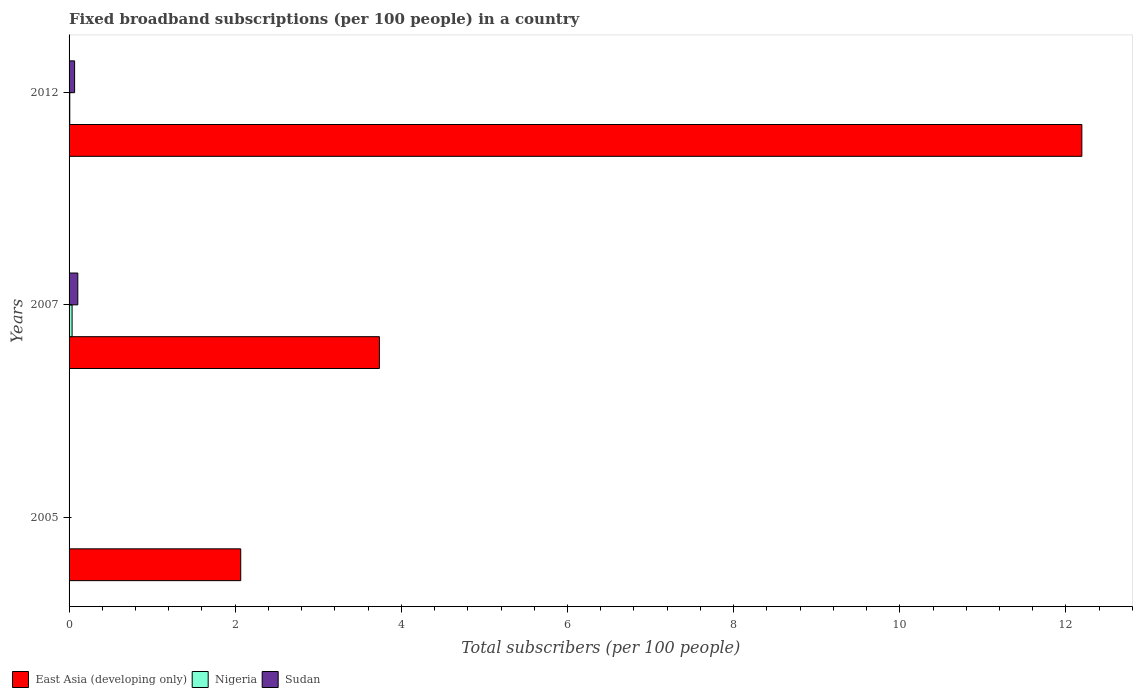How many groups of bars are there?
Provide a short and direct response. 3. Are the number of bars per tick equal to the number of legend labels?
Make the answer very short. Yes. Are the number of bars on each tick of the Y-axis equal?
Offer a very short reply. Yes. How many bars are there on the 2nd tick from the top?
Keep it short and to the point. 3. In how many cases, is the number of bars for a given year not equal to the number of legend labels?
Ensure brevity in your answer.  0. What is the number of broadband subscriptions in Sudan in 2005?
Keep it short and to the point. 0. Across all years, what is the maximum number of broadband subscriptions in Sudan?
Your response must be concise. 0.11. Across all years, what is the minimum number of broadband subscriptions in East Asia (developing only)?
Offer a very short reply. 2.07. What is the total number of broadband subscriptions in Nigeria in the graph?
Ensure brevity in your answer.  0.05. What is the difference between the number of broadband subscriptions in East Asia (developing only) in 2005 and that in 2007?
Keep it short and to the point. -1.67. What is the difference between the number of broadband subscriptions in Sudan in 2007 and the number of broadband subscriptions in Nigeria in 2012?
Provide a short and direct response. 0.1. What is the average number of broadband subscriptions in East Asia (developing only) per year?
Your answer should be very brief. 6. In the year 2005, what is the difference between the number of broadband subscriptions in Sudan and number of broadband subscriptions in Nigeria?
Keep it short and to the point. 0. What is the ratio of the number of broadband subscriptions in East Asia (developing only) in 2007 to that in 2012?
Your response must be concise. 0.31. Is the number of broadband subscriptions in East Asia (developing only) in 2005 less than that in 2012?
Keep it short and to the point. Yes. Is the difference between the number of broadband subscriptions in Sudan in 2005 and 2012 greater than the difference between the number of broadband subscriptions in Nigeria in 2005 and 2012?
Offer a terse response. No. What is the difference between the highest and the second highest number of broadband subscriptions in Nigeria?
Ensure brevity in your answer.  0.03. What is the difference between the highest and the lowest number of broadband subscriptions in East Asia (developing only)?
Offer a terse response. 10.13. In how many years, is the number of broadband subscriptions in East Asia (developing only) greater than the average number of broadband subscriptions in East Asia (developing only) taken over all years?
Provide a succinct answer. 1. Is the sum of the number of broadband subscriptions in Nigeria in 2005 and 2012 greater than the maximum number of broadband subscriptions in Sudan across all years?
Offer a very short reply. No. What does the 2nd bar from the top in 2005 represents?
Give a very brief answer. Nigeria. What does the 1st bar from the bottom in 2012 represents?
Offer a very short reply. East Asia (developing only). Are all the bars in the graph horizontal?
Offer a very short reply. Yes. Does the graph contain any zero values?
Give a very brief answer. No. Does the graph contain grids?
Offer a very short reply. No. Where does the legend appear in the graph?
Make the answer very short. Bottom left. How many legend labels are there?
Your answer should be very brief. 3. How are the legend labels stacked?
Offer a terse response. Horizontal. What is the title of the graph?
Ensure brevity in your answer.  Fixed broadband subscriptions (per 100 people) in a country. What is the label or title of the X-axis?
Your answer should be very brief. Total subscribers (per 100 people). What is the Total subscribers (per 100 people) in East Asia (developing only) in 2005?
Your response must be concise. 2.07. What is the Total subscribers (per 100 people) of Nigeria in 2005?
Make the answer very short. 0. What is the Total subscribers (per 100 people) of Sudan in 2005?
Offer a very short reply. 0. What is the Total subscribers (per 100 people) in East Asia (developing only) in 2007?
Give a very brief answer. 3.74. What is the Total subscribers (per 100 people) of Nigeria in 2007?
Provide a succinct answer. 0.04. What is the Total subscribers (per 100 people) of Sudan in 2007?
Ensure brevity in your answer.  0.11. What is the Total subscribers (per 100 people) in East Asia (developing only) in 2012?
Your answer should be compact. 12.19. What is the Total subscribers (per 100 people) in Nigeria in 2012?
Your response must be concise. 0.01. What is the Total subscribers (per 100 people) of Sudan in 2012?
Keep it short and to the point. 0.07. Across all years, what is the maximum Total subscribers (per 100 people) of East Asia (developing only)?
Give a very brief answer. 12.19. Across all years, what is the maximum Total subscribers (per 100 people) of Nigeria?
Provide a short and direct response. 0.04. Across all years, what is the maximum Total subscribers (per 100 people) of Sudan?
Your answer should be compact. 0.11. Across all years, what is the minimum Total subscribers (per 100 people) of East Asia (developing only)?
Your response must be concise. 2.07. Across all years, what is the minimum Total subscribers (per 100 people) in Nigeria?
Offer a very short reply. 0. Across all years, what is the minimum Total subscribers (per 100 people) in Sudan?
Offer a terse response. 0. What is the total Total subscribers (per 100 people) of East Asia (developing only) in the graph?
Your answer should be very brief. 17.99. What is the total Total subscribers (per 100 people) in Nigeria in the graph?
Your response must be concise. 0.05. What is the total Total subscribers (per 100 people) in Sudan in the graph?
Ensure brevity in your answer.  0.18. What is the difference between the Total subscribers (per 100 people) of East Asia (developing only) in 2005 and that in 2007?
Provide a succinct answer. -1.67. What is the difference between the Total subscribers (per 100 people) of Nigeria in 2005 and that in 2007?
Give a very brief answer. -0.04. What is the difference between the Total subscribers (per 100 people) in Sudan in 2005 and that in 2007?
Ensure brevity in your answer.  -0.1. What is the difference between the Total subscribers (per 100 people) in East Asia (developing only) in 2005 and that in 2012?
Provide a succinct answer. -10.13. What is the difference between the Total subscribers (per 100 people) in Nigeria in 2005 and that in 2012?
Your answer should be very brief. -0.01. What is the difference between the Total subscribers (per 100 people) of Sudan in 2005 and that in 2012?
Provide a short and direct response. -0.06. What is the difference between the Total subscribers (per 100 people) in East Asia (developing only) in 2007 and that in 2012?
Keep it short and to the point. -8.46. What is the difference between the Total subscribers (per 100 people) of Nigeria in 2007 and that in 2012?
Make the answer very short. 0.03. What is the difference between the Total subscribers (per 100 people) of Sudan in 2007 and that in 2012?
Offer a very short reply. 0.04. What is the difference between the Total subscribers (per 100 people) of East Asia (developing only) in 2005 and the Total subscribers (per 100 people) of Nigeria in 2007?
Your answer should be compact. 2.03. What is the difference between the Total subscribers (per 100 people) of East Asia (developing only) in 2005 and the Total subscribers (per 100 people) of Sudan in 2007?
Make the answer very short. 1.96. What is the difference between the Total subscribers (per 100 people) in Nigeria in 2005 and the Total subscribers (per 100 people) in Sudan in 2007?
Offer a terse response. -0.1. What is the difference between the Total subscribers (per 100 people) of East Asia (developing only) in 2005 and the Total subscribers (per 100 people) of Nigeria in 2012?
Offer a very short reply. 2.06. What is the difference between the Total subscribers (per 100 people) of East Asia (developing only) in 2005 and the Total subscribers (per 100 people) of Sudan in 2012?
Provide a short and direct response. 2. What is the difference between the Total subscribers (per 100 people) in Nigeria in 2005 and the Total subscribers (per 100 people) in Sudan in 2012?
Your response must be concise. -0.07. What is the difference between the Total subscribers (per 100 people) in East Asia (developing only) in 2007 and the Total subscribers (per 100 people) in Nigeria in 2012?
Ensure brevity in your answer.  3.73. What is the difference between the Total subscribers (per 100 people) in East Asia (developing only) in 2007 and the Total subscribers (per 100 people) in Sudan in 2012?
Provide a succinct answer. 3.67. What is the difference between the Total subscribers (per 100 people) of Nigeria in 2007 and the Total subscribers (per 100 people) of Sudan in 2012?
Your answer should be very brief. -0.03. What is the average Total subscribers (per 100 people) of East Asia (developing only) per year?
Your answer should be very brief. 6. What is the average Total subscribers (per 100 people) of Nigeria per year?
Make the answer very short. 0.02. What is the average Total subscribers (per 100 people) of Sudan per year?
Your answer should be very brief. 0.06. In the year 2005, what is the difference between the Total subscribers (per 100 people) in East Asia (developing only) and Total subscribers (per 100 people) in Nigeria?
Ensure brevity in your answer.  2.07. In the year 2005, what is the difference between the Total subscribers (per 100 people) of East Asia (developing only) and Total subscribers (per 100 people) of Sudan?
Your response must be concise. 2.06. In the year 2005, what is the difference between the Total subscribers (per 100 people) of Nigeria and Total subscribers (per 100 people) of Sudan?
Make the answer very short. -0. In the year 2007, what is the difference between the Total subscribers (per 100 people) of East Asia (developing only) and Total subscribers (per 100 people) of Nigeria?
Your answer should be very brief. 3.7. In the year 2007, what is the difference between the Total subscribers (per 100 people) in East Asia (developing only) and Total subscribers (per 100 people) in Sudan?
Give a very brief answer. 3.63. In the year 2007, what is the difference between the Total subscribers (per 100 people) of Nigeria and Total subscribers (per 100 people) of Sudan?
Provide a short and direct response. -0.07. In the year 2012, what is the difference between the Total subscribers (per 100 people) in East Asia (developing only) and Total subscribers (per 100 people) in Nigeria?
Your response must be concise. 12.18. In the year 2012, what is the difference between the Total subscribers (per 100 people) of East Asia (developing only) and Total subscribers (per 100 people) of Sudan?
Offer a very short reply. 12.13. In the year 2012, what is the difference between the Total subscribers (per 100 people) of Nigeria and Total subscribers (per 100 people) of Sudan?
Give a very brief answer. -0.06. What is the ratio of the Total subscribers (per 100 people) of East Asia (developing only) in 2005 to that in 2007?
Your answer should be very brief. 0.55. What is the ratio of the Total subscribers (per 100 people) of Nigeria in 2005 to that in 2007?
Keep it short and to the point. 0.01. What is the ratio of the Total subscribers (per 100 people) of Sudan in 2005 to that in 2007?
Your response must be concise. 0.03. What is the ratio of the Total subscribers (per 100 people) in East Asia (developing only) in 2005 to that in 2012?
Ensure brevity in your answer.  0.17. What is the ratio of the Total subscribers (per 100 people) of Nigeria in 2005 to that in 2012?
Give a very brief answer. 0.04. What is the ratio of the Total subscribers (per 100 people) of Sudan in 2005 to that in 2012?
Ensure brevity in your answer.  0.05. What is the ratio of the Total subscribers (per 100 people) of East Asia (developing only) in 2007 to that in 2012?
Your response must be concise. 0.31. What is the ratio of the Total subscribers (per 100 people) in Nigeria in 2007 to that in 2012?
Your answer should be very brief. 4.31. What is the ratio of the Total subscribers (per 100 people) of Sudan in 2007 to that in 2012?
Your answer should be compact. 1.58. What is the difference between the highest and the second highest Total subscribers (per 100 people) in East Asia (developing only)?
Ensure brevity in your answer.  8.46. What is the difference between the highest and the second highest Total subscribers (per 100 people) in Nigeria?
Provide a succinct answer. 0.03. What is the difference between the highest and the second highest Total subscribers (per 100 people) of Sudan?
Provide a succinct answer. 0.04. What is the difference between the highest and the lowest Total subscribers (per 100 people) of East Asia (developing only)?
Offer a very short reply. 10.13. What is the difference between the highest and the lowest Total subscribers (per 100 people) in Nigeria?
Your answer should be compact. 0.04. What is the difference between the highest and the lowest Total subscribers (per 100 people) of Sudan?
Make the answer very short. 0.1. 